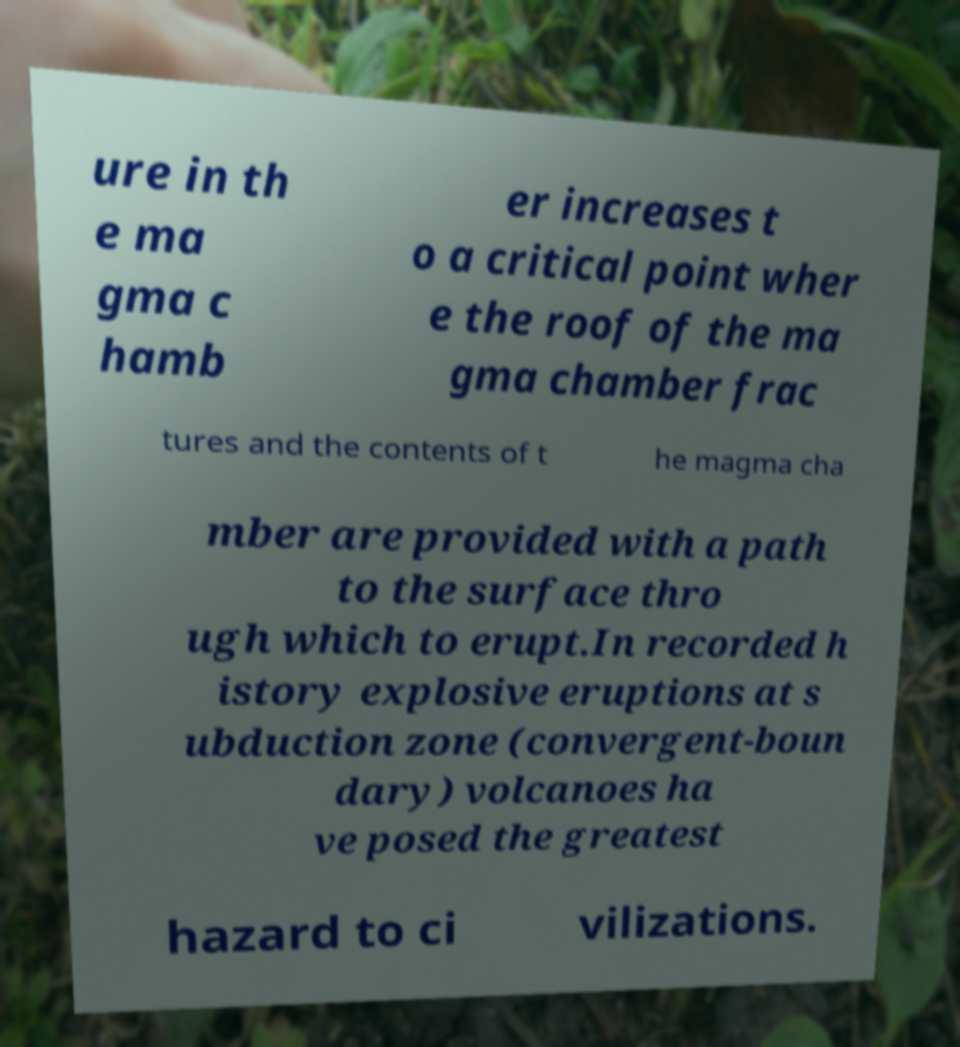I need the written content from this picture converted into text. Can you do that? ure in th e ma gma c hamb er increases t o a critical point wher e the roof of the ma gma chamber frac tures and the contents of t he magma cha mber are provided with a path to the surface thro ugh which to erupt.In recorded h istory explosive eruptions at s ubduction zone (convergent-boun dary) volcanoes ha ve posed the greatest hazard to ci vilizations. 